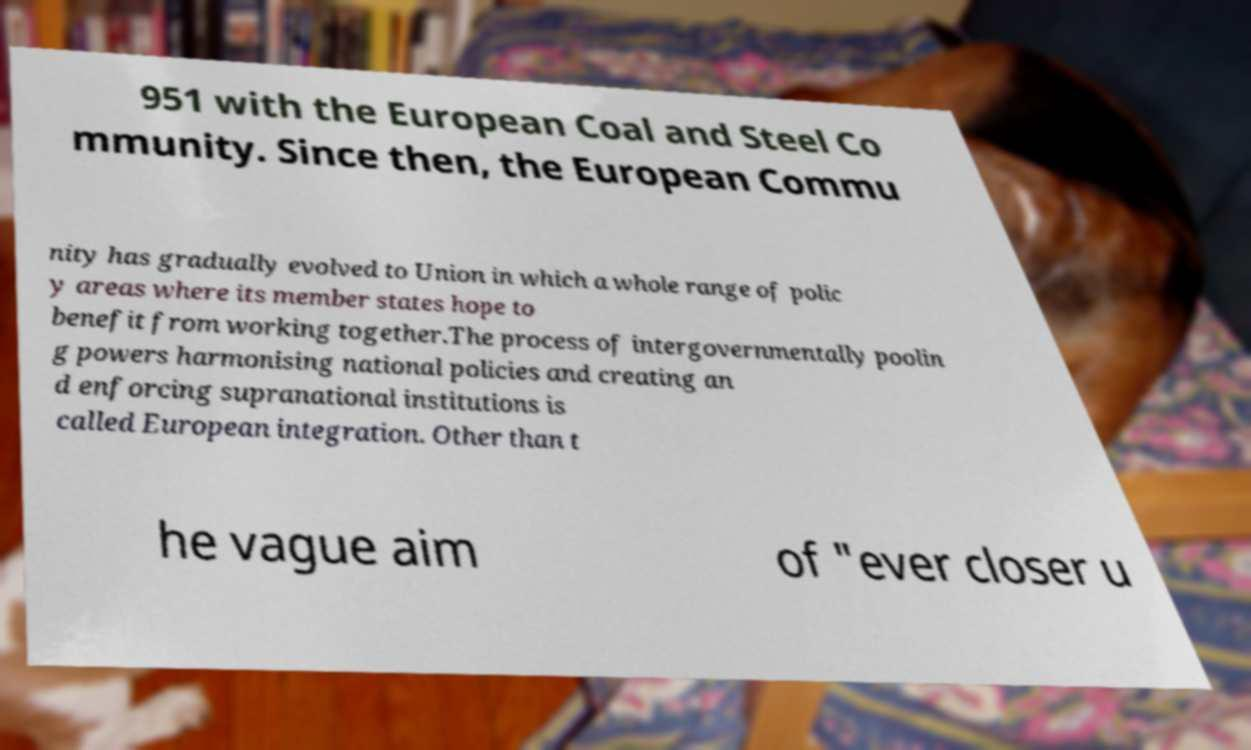Please identify and transcribe the text found in this image. 951 with the European Coal and Steel Co mmunity. Since then, the European Commu nity has gradually evolved to Union in which a whole range of polic y areas where its member states hope to benefit from working together.The process of intergovernmentally poolin g powers harmonising national policies and creating an d enforcing supranational institutions is called European integration. Other than t he vague aim of "ever closer u 